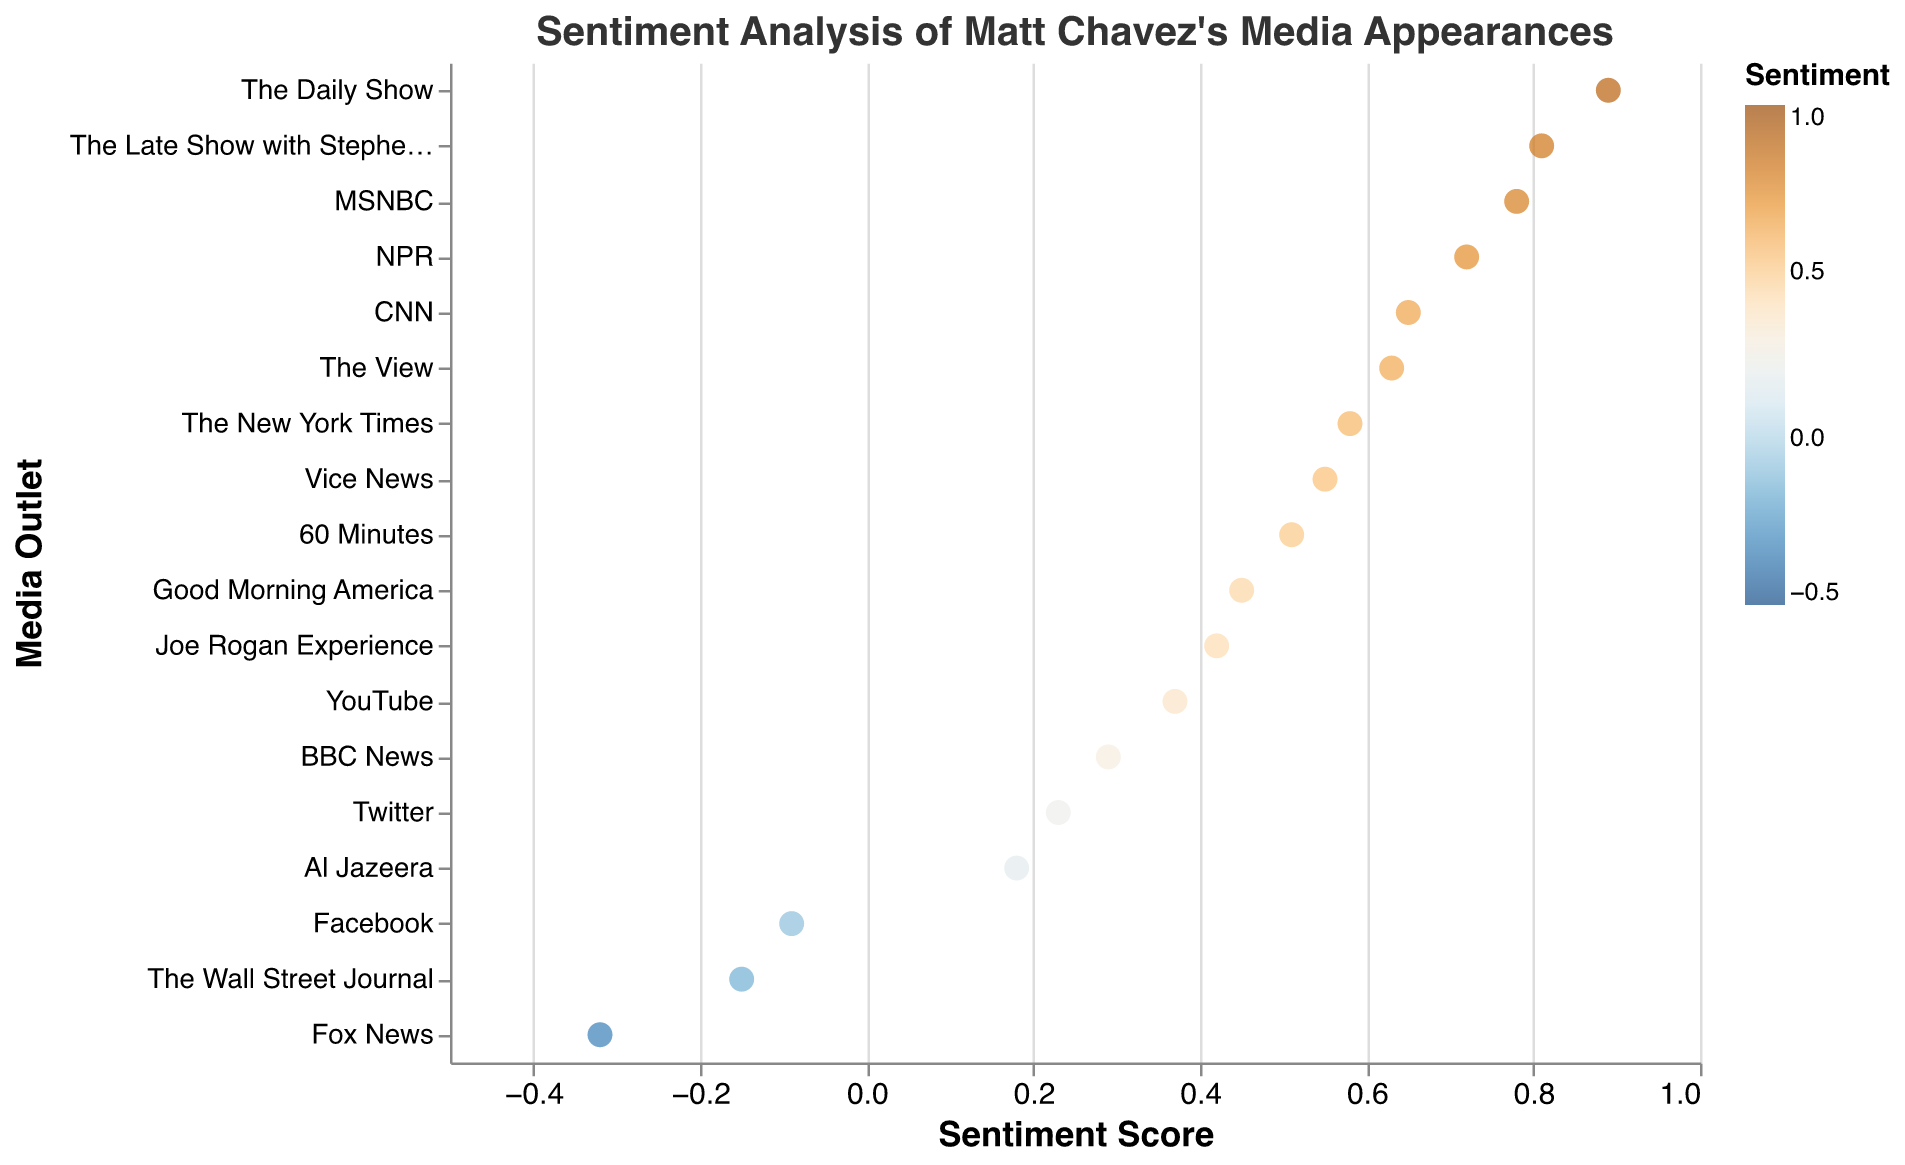What is the highest sentiment score in the plot? Look for the data point with the highest position along the x-axis labeled "Sentiment Score". The highest score is shown for The Daily Show.
Answer: 0.89 Which media outlet has the lowest sentiment score? Look for the data point with the lowest position along the x-axis labeled "Sentiment Score". The lowest score is shown for Fox News.
Answer: Fox News How many media outlets have a sentiment score above 0.5? Count the number of points that are positioned to the right of the 0.5 mark on the x-axis. The outlets with scores above 0.5 are: CNN, MSNBC, The Daily Show, NPR, The New York Times, The Late Show with Stephen Colbert, The View, and Vice News.
Answer: 8 Which media outlet has a sentiment score closest to 0? Look for the data point nearest to the 0 mark on the x-axis. The closest score to 0 is shown for Facebook.
Answer: Facebook What is the average sentiment score of all media outlets? Sum up all the sentiment scores and divide by the total number of media outlets. Sum = 0.65 - 0.32 + 0.78 + 0.42 + 0.89 + 0.51 + 0.72 + 0.58 - 0.15 + 0.23 - 0.09 + 0.37 + 0.81 + 0.45 + 0.63 + 0.29 + 0.18 + 0.55 = 7.51. The total number of outlets is 18. The average is 7.51 / 18.
Answer: 0.42 Compare the sentiment scores of CNN and The New York Times. Which one is higher, and by how much? Look at the sentiment scores for both CNN (0.65) and The New York Times (0.58). Subtract New York Times’ score from CNN’s score. 0.65 - 0.58 = 0.07.
Answer: CNN by 0.07 What is the median sentiment score for the media outlets? Arrange the sentiment scores in ascending order: -0.32, -0.15, -0.09, 0.18, 0.23, 0.29, 0.37, 0.42, 0.45, 0.51, 0.55, 0.58, 0.63, 0.65, 0.72, 0.78, 0.81, 0.89. The median is the middle value in this ordered list. With 18 values, the median is the average of the 9th and 10th values. (0.45 + 0.51) / 2 = 0.48.
Answer: 0.48 Which media outlet has a sentiment score exactly equal to 0.37? Look at the data points and find the one with a sentiment score of 0.37. The outlet is YouTube.
Answer: YouTube What is the range of the sentiment scores in the plot? Subtract the smallest sentiment score from the largest sentiment score. Largest score is 0.89 (The Daily Show), smallest score is -0.32 (Fox News). 0.89 - (-0.32) = 1.21.
Answer: 1.21 